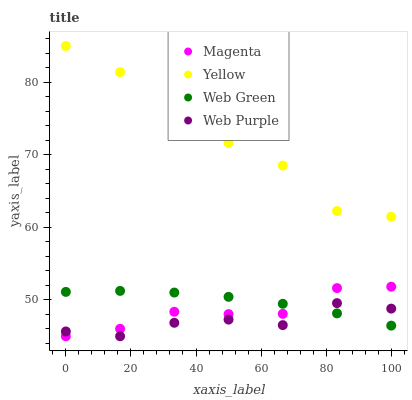Does Web Purple have the minimum area under the curve?
Answer yes or no. Yes. Does Yellow have the maximum area under the curve?
Answer yes or no. Yes. Does Magenta have the minimum area under the curve?
Answer yes or no. No. Does Magenta have the maximum area under the curve?
Answer yes or no. No. Is Web Green the smoothest?
Answer yes or no. Yes. Is Web Purple the roughest?
Answer yes or no. Yes. Is Magenta the smoothest?
Answer yes or no. No. Is Magenta the roughest?
Answer yes or no. No. Does Web Purple have the lowest value?
Answer yes or no. Yes. Does Web Green have the lowest value?
Answer yes or no. No. Does Yellow have the highest value?
Answer yes or no. Yes. Does Magenta have the highest value?
Answer yes or no. No. Is Magenta less than Yellow?
Answer yes or no. Yes. Is Yellow greater than Web Purple?
Answer yes or no. Yes. Does Web Green intersect Magenta?
Answer yes or no. Yes. Is Web Green less than Magenta?
Answer yes or no. No. Is Web Green greater than Magenta?
Answer yes or no. No. Does Magenta intersect Yellow?
Answer yes or no. No. 